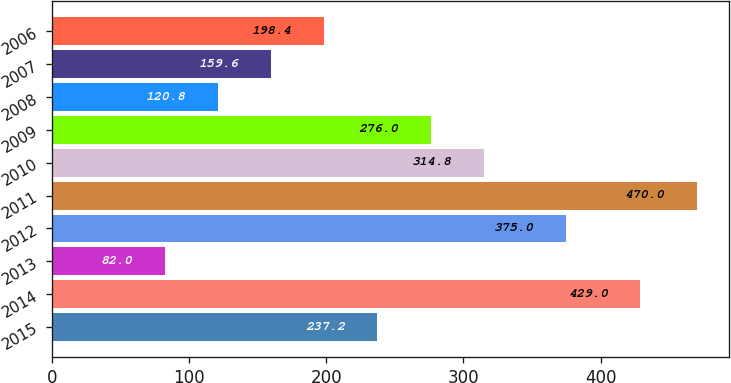<chart> <loc_0><loc_0><loc_500><loc_500><bar_chart><fcel>2015<fcel>2014<fcel>2013<fcel>2012<fcel>2011<fcel>2010<fcel>2009<fcel>2008<fcel>2007<fcel>2006<nl><fcel>237.2<fcel>429<fcel>82<fcel>375<fcel>470<fcel>314.8<fcel>276<fcel>120.8<fcel>159.6<fcel>198.4<nl></chart> 